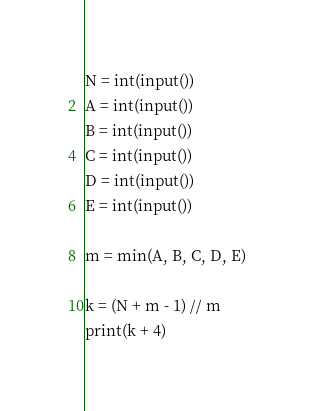Convert code to text. <code><loc_0><loc_0><loc_500><loc_500><_Python_>N = int(input())
A = int(input())
B = int(input())
C = int(input())
D = int(input())
E = int(input())

m = min(A, B, C, D, E)

k = (N + m - 1) // m
print(k + 4)
</code> 